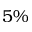<formula> <loc_0><loc_0><loc_500><loc_500>5 \%</formula> 